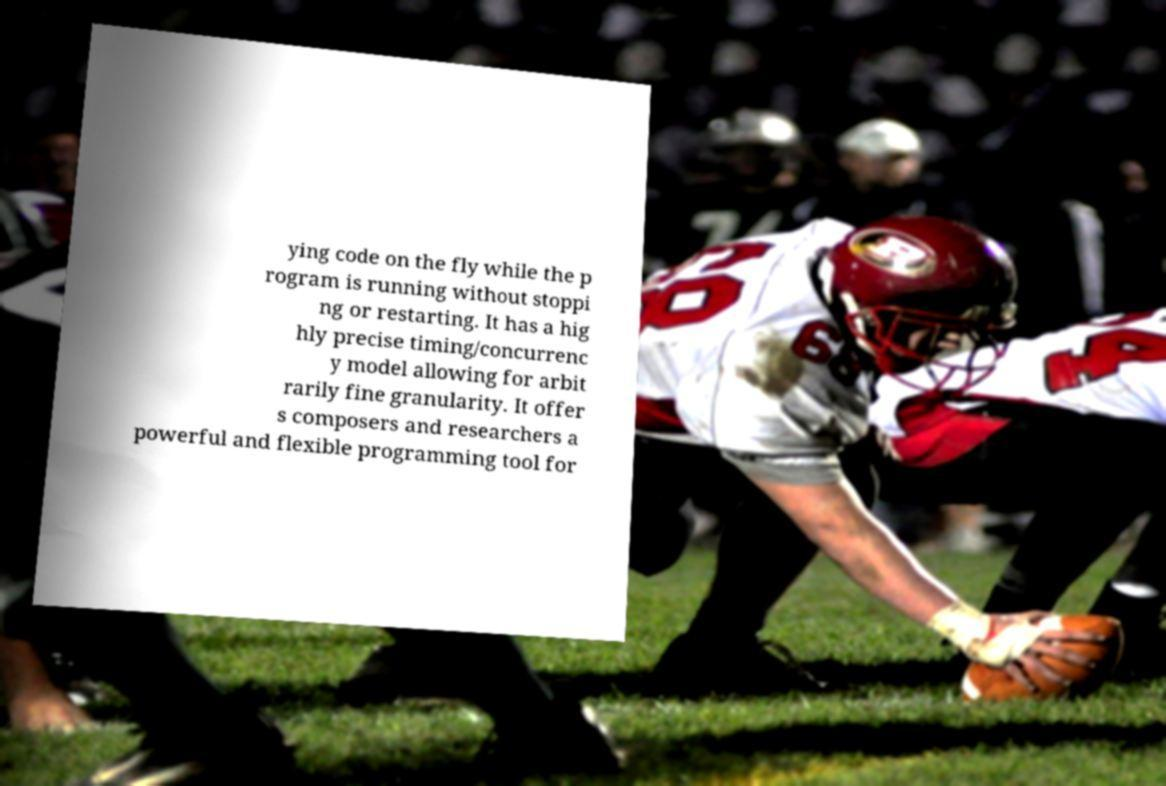Could you extract and type out the text from this image? ying code on the fly while the p rogram is running without stoppi ng or restarting. It has a hig hly precise timing/concurrenc y model allowing for arbit rarily fine granularity. It offer s composers and researchers a powerful and flexible programming tool for 